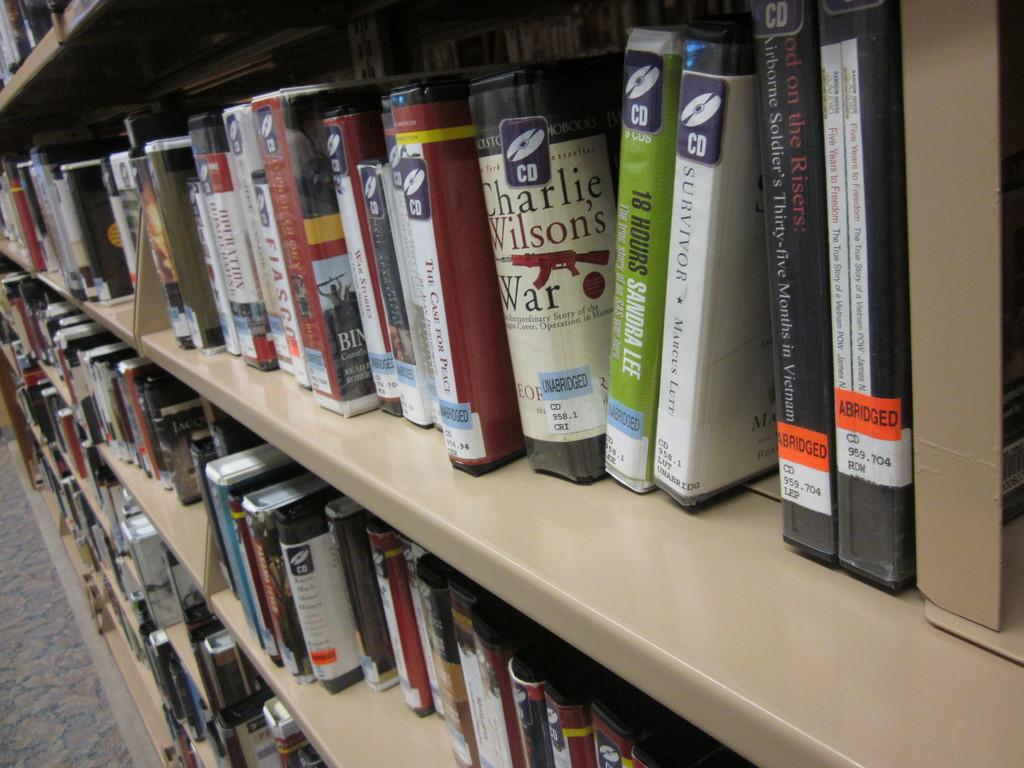Provide a one-sentence caption for the provided image. Bunch of books on a shelf with a green one that says 18 hours. 